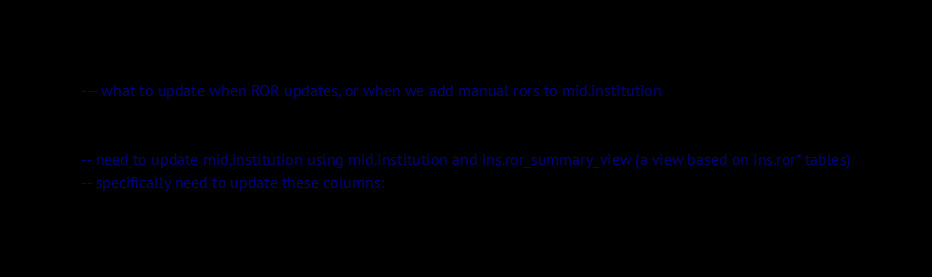<code> <loc_0><loc_0><loc_500><loc_500><_SQL_>--- what to update when ROR updates, or when we add manual rors to mid.institution


-- need to update mid.institution using mid.institution and ins.ror_summary_view (a view based on ins.ror* tables)
-- specifically need to update these columns:</code> 